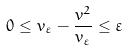<formula> <loc_0><loc_0><loc_500><loc_500>0 \leq v _ { \varepsilon } - \frac { v ^ { 2 } } { v _ { \varepsilon } } \leq \varepsilon</formula> 